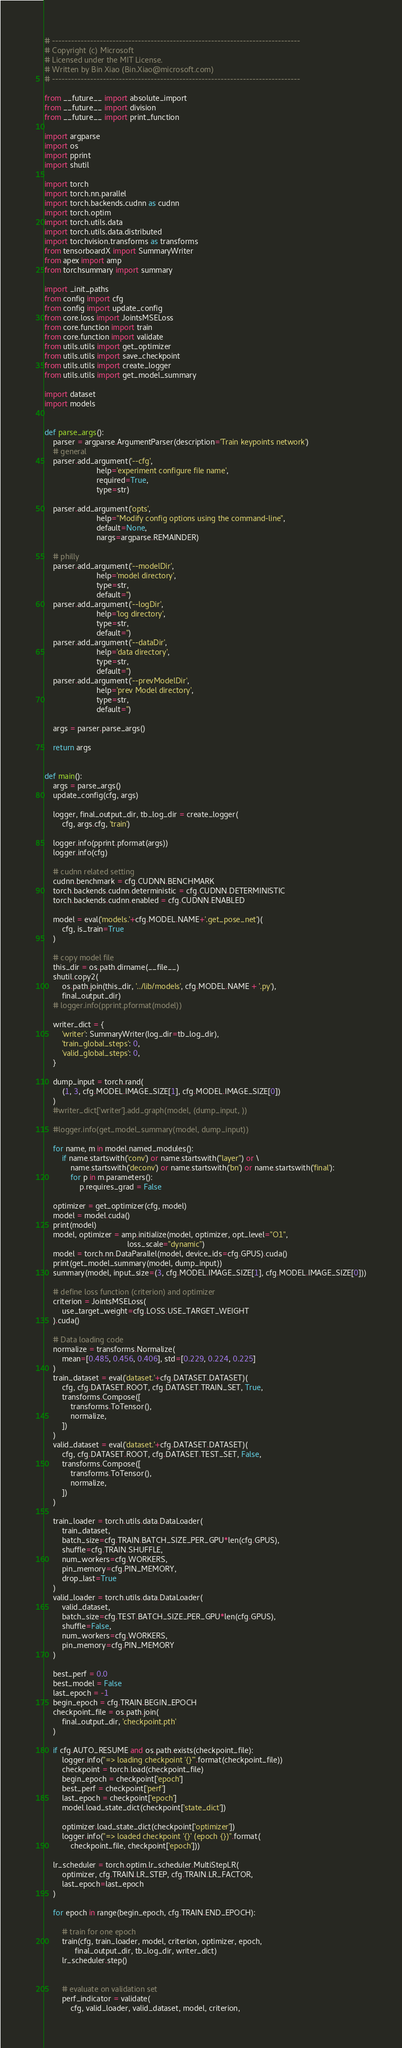Convert code to text. <code><loc_0><loc_0><loc_500><loc_500><_Python_># ------------------------------------------------------------------------------
# Copyright (c) Microsoft
# Licensed under the MIT License.
# Written by Bin Xiao (Bin.Xiao@microsoft.com)
# ------------------------------------------------------------------------------

from __future__ import absolute_import
from __future__ import division
from __future__ import print_function

import argparse
import os
import pprint
import shutil

import torch
import torch.nn.parallel
import torch.backends.cudnn as cudnn
import torch.optim
import torch.utils.data
import torch.utils.data.distributed
import torchvision.transforms as transforms
from tensorboardX import SummaryWriter
from apex import amp
from torchsummary import summary

import _init_paths
from config import cfg
from config import update_config
from core.loss import JointsMSELoss
from core.function import train
from core.function import validate
from utils.utils import get_optimizer
from utils.utils import save_checkpoint
from utils.utils import create_logger
from utils.utils import get_model_summary

import dataset
import models


def parse_args():
    parser = argparse.ArgumentParser(description='Train keypoints network')
    # general
    parser.add_argument('--cfg',
                        help='experiment configure file name',
                        required=True,
                        type=str)

    parser.add_argument('opts',
                        help="Modify config options using the command-line",
                        default=None,
                        nargs=argparse.REMAINDER)

    # philly
    parser.add_argument('--modelDir',
                        help='model directory',
                        type=str,
                        default='')
    parser.add_argument('--logDir',
                        help='log directory',
                        type=str,
                        default='')
    parser.add_argument('--dataDir',
                        help='data directory',
                        type=str,
                        default='')
    parser.add_argument('--prevModelDir',
                        help='prev Model directory',
                        type=str,
                        default='')

    args = parser.parse_args()

    return args


def main():
    args = parse_args()
    update_config(cfg, args)

    logger, final_output_dir, tb_log_dir = create_logger(
        cfg, args.cfg, 'train')

    logger.info(pprint.pformat(args))
    logger.info(cfg)

    # cudnn related setting
    cudnn.benchmark = cfg.CUDNN.BENCHMARK
    torch.backends.cudnn.deterministic = cfg.CUDNN.DETERMINISTIC
    torch.backends.cudnn.enabled = cfg.CUDNN.ENABLED

    model = eval('models.'+cfg.MODEL.NAME+'.get_pose_net')(
        cfg, is_train=True
    )

    # copy model file
    this_dir = os.path.dirname(__file__)
    shutil.copy2(
        os.path.join(this_dir, '../lib/models', cfg.MODEL.NAME + '.py'),
        final_output_dir)
    # logger.info(pprint.pformat(model))

    writer_dict = {
        'writer': SummaryWriter(log_dir=tb_log_dir),
        'train_global_steps': 0,
        'valid_global_steps': 0,
    }

    dump_input = torch.rand(
        (1, 3, cfg.MODEL.IMAGE_SIZE[1], cfg.MODEL.IMAGE_SIZE[0])
    )
    #writer_dict['writer'].add_graph(model, (dump_input, ))

    #logger.info(get_model_summary(model, dump_input))

    for name, m in model.named_modules():
        if name.startswith('conv') or name.startswith("layer") or \
            name.startswith('deconv') or name.startswith('bn') or name.startswith('final'):
            for p in m.parameters():
                p.requires_grad = False

    optimizer = get_optimizer(cfg, model)
    model = model.cuda()
    print(model)
    model, optimizer = amp.initialize(model, optimizer, opt_level="O1",
                                      loss_scale="dynamic")
    model = torch.nn.DataParallel(model, device_ids=cfg.GPUS).cuda()
    print(get_model_summary(model, dump_input))
    summary(model, input_size=(3, cfg.MODEL.IMAGE_SIZE[1], cfg.MODEL.IMAGE_SIZE[0]))

    # define loss function (criterion) and optimizer
    criterion = JointsMSELoss(
        use_target_weight=cfg.LOSS.USE_TARGET_WEIGHT
    ).cuda()

    # Data loading code
    normalize = transforms.Normalize(
        mean=[0.485, 0.456, 0.406], std=[0.229, 0.224, 0.225]
    )
    train_dataset = eval('dataset.'+cfg.DATASET.DATASET)(
        cfg, cfg.DATASET.ROOT, cfg.DATASET.TRAIN_SET, True,
        transforms.Compose([
            transforms.ToTensor(),
            normalize,
        ])
    )
    valid_dataset = eval('dataset.'+cfg.DATASET.DATASET)(
        cfg, cfg.DATASET.ROOT, cfg.DATASET.TEST_SET, False,
        transforms.Compose([
            transforms.ToTensor(),
            normalize,
        ])
    )

    train_loader = torch.utils.data.DataLoader(
        train_dataset,
        batch_size=cfg.TRAIN.BATCH_SIZE_PER_GPU*len(cfg.GPUS),
        shuffle=cfg.TRAIN.SHUFFLE,
        num_workers=cfg.WORKERS,
        pin_memory=cfg.PIN_MEMORY,
        drop_last=True
    )
    valid_loader = torch.utils.data.DataLoader(
        valid_dataset,
        batch_size=cfg.TEST.BATCH_SIZE_PER_GPU*len(cfg.GPUS),
        shuffle=False,
        num_workers=cfg.WORKERS,
        pin_memory=cfg.PIN_MEMORY
    )

    best_perf = 0.0
    best_model = False
    last_epoch = -1
    begin_epoch = cfg.TRAIN.BEGIN_EPOCH
    checkpoint_file = os.path.join(
        final_output_dir, 'checkpoint.pth'
    )

    if cfg.AUTO_RESUME and os.path.exists(checkpoint_file):
        logger.info("=> loading checkpoint '{}'".format(checkpoint_file))
        checkpoint = torch.load(checkpoint_file)
        begin_epoch = checkpoint['epoch']
        best_perf = checkpoint['perf']
        last_epoch = checkpoint['epoch']
        model.load_state_dict(checkpoint['state_dict'])

        optimizer.load_state_dict(checkpoint['optimizer'])
        logger.info("=> loaded checkpoint '{}' (epoch {})".format(
            checkpoint_file, checkpoint['epoch']))

    lr_scheduler = torch.optim.lr_scheduler.MultiStepLR(
        optimizer, cfg.TRAIN.LR_STEP, cfg.TRAIN.LR_FACTOR,
        last_epoch=last_epoch
    )

    for epoch in range(begin_epoch, cfg.TRAIN.END_EPOCH):

        # train for one epoch
        train(cfg, train_loader, model, criterion, optimizer, epoch,
              final_output_dir, tb_log_dir, writer_dict)
        lr_scheduler.step()


        # evaluate on validation set
        perf_indicator = validate(
            cfg, valid_loader, valid_dataset, model, criterion,</code> 